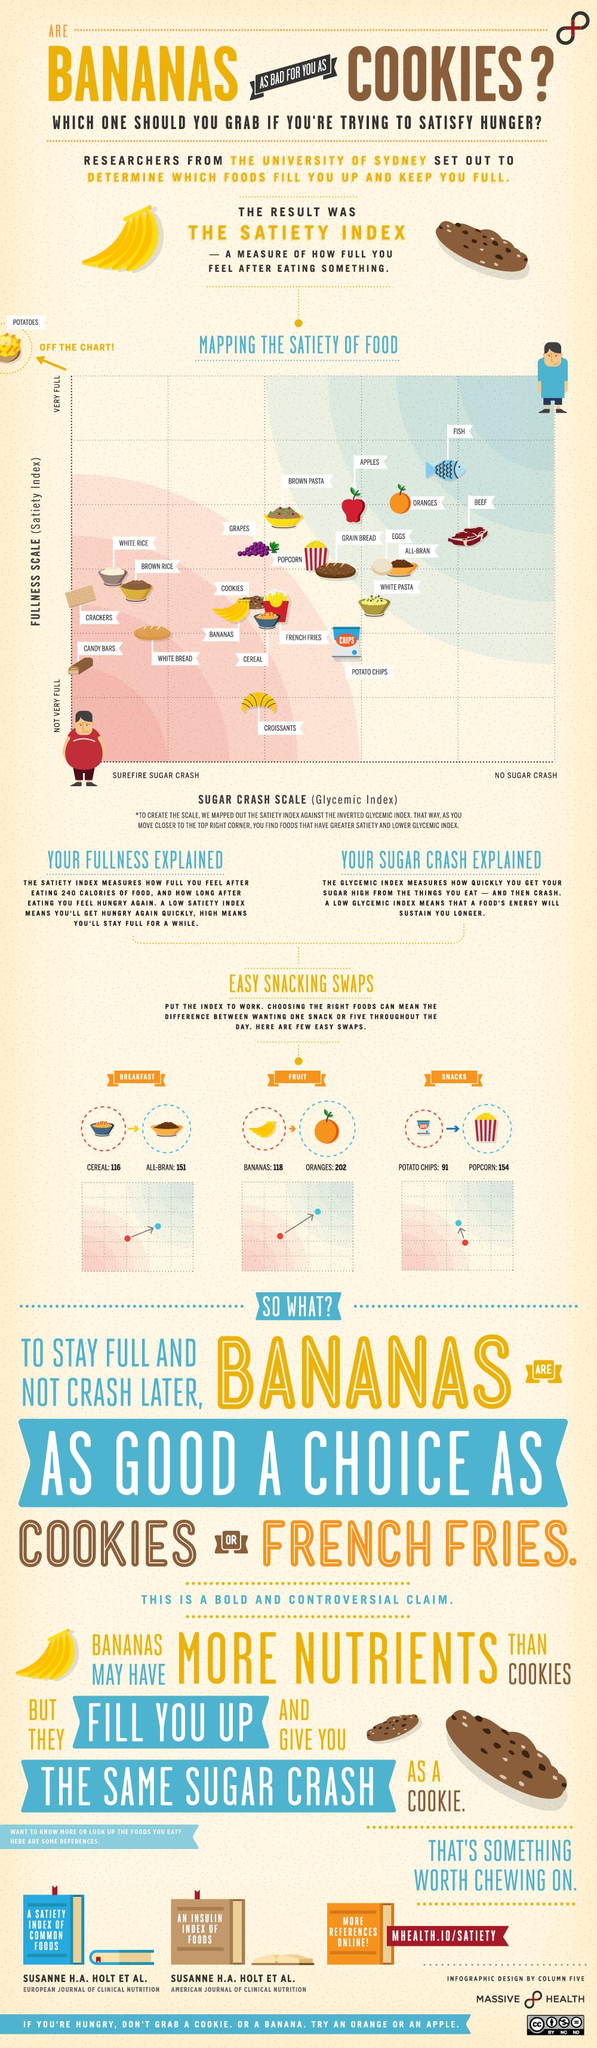Draw attention to some important aspects in this diagram. Instead of cereal, bananas, popcorn, or all-bran, one should have [all-bran]. It is recommended to swap bananas with cereal, all-bran, or oranges, with a preference towards oranges. Popcorn should be swapped with bananas, oranges, or potato crisps in order to create a healthier and more diverse snack option. Fish is the food that provides the highest satiety and has the lowest sugar crash scale. Candy bars are considered to have the lowest satiety and the highest sugar crash scale compared to other types of food. 